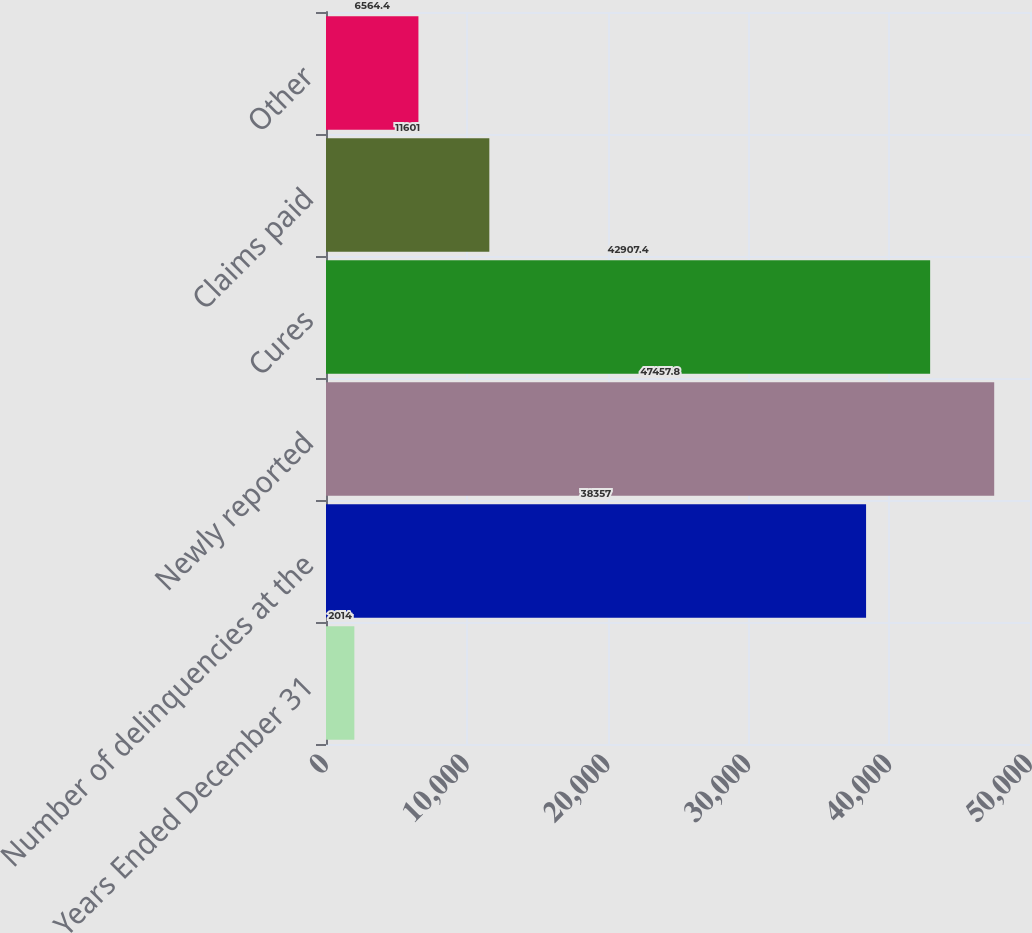Convert chart. <chart><loc_0><loc_0><loc_500><loc_500><bar_chart><fcel>Years Ended December 31<fcel>Number of delinquencies at the<fcel>Newly reported<fcel>Cures<fcel>Claims paid<fcel>Other<nl><fcel>2014<fcel>38357<fcel>47457.8<fcel>42907.4<fcel>11601<fcel>6564.4<nl></chart> 